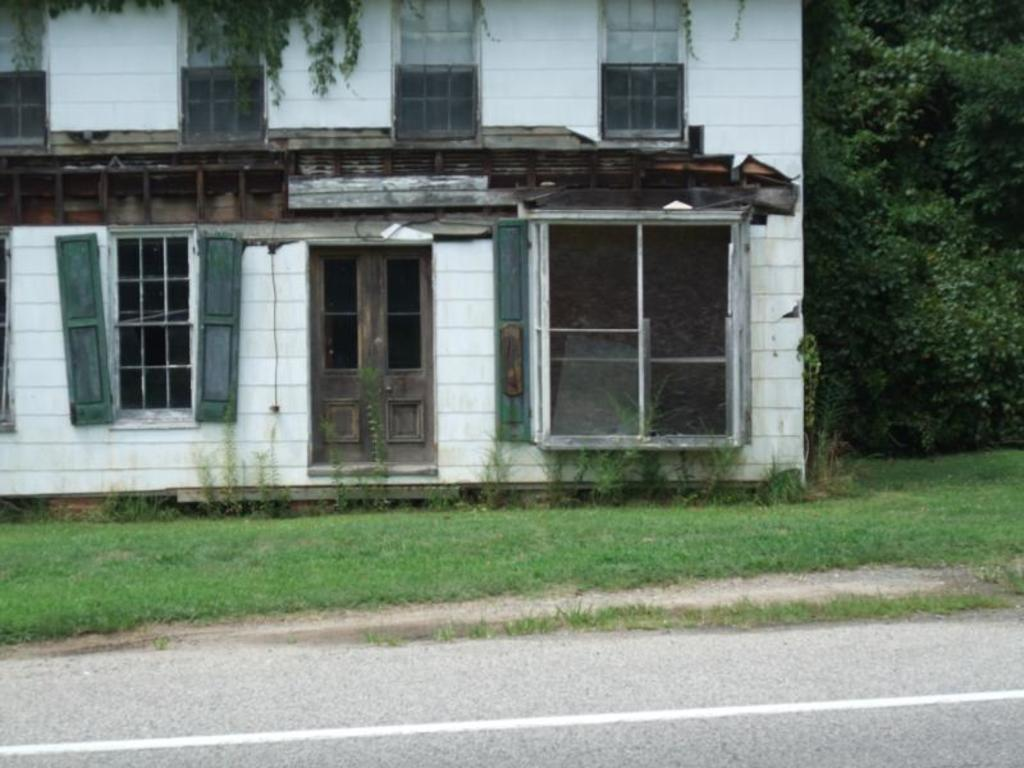What type of structure is visible in the image? There is a building in the image. What features can be seen on the building? The building has a door and windows. What is in front of the building? There is grass and a road in front of the building. What can be seen on the right side of the image? There are trees on the right side of the image. What type of meal is being served in the building in the image? There is no indication of a meal being served in the building or anywhere in the image. 